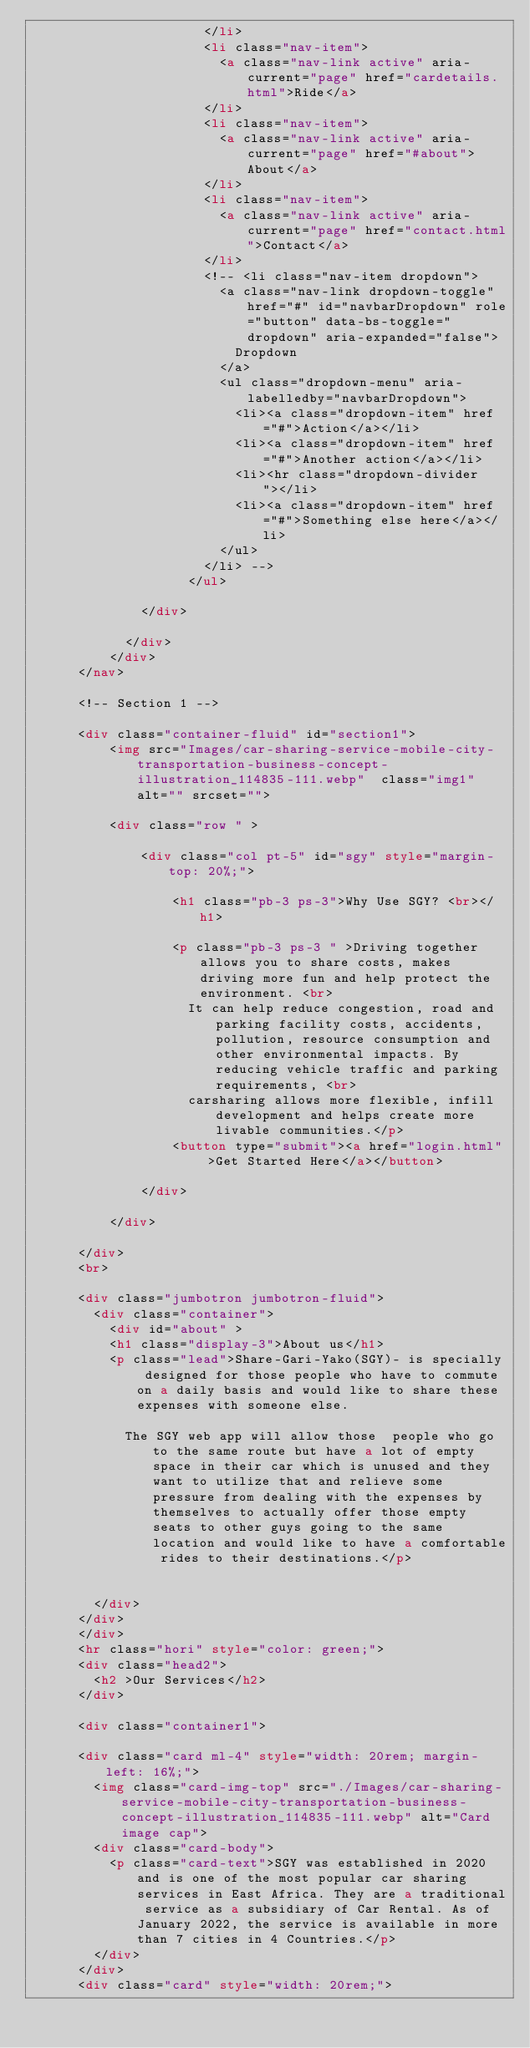Convert code to text. <code><loc_0><loc_0><loc_500><loc_500><_HTML_>                      </li>
                      <li class="nav-item">
                        <a class="nav-link active" aria-current="page" href="cardetails.html">Ride</a>
                      </li>
                      <li class="nav-item">
                        <a class="nav-link active" aria-current="page" href="#about">About</a>
                      </li>
                      <li class="nav-item">
                        <a class="nav-link active" aria-current="page" href="contact.html">Contact</a>
                      </li>
                      <!-- <li class="nav-item dropdown">
                        <a class="nav-link dropdown-toggle" href="#" id="navbarDropdown" role="button" data-bs-toggle="dropdown" aria-expanded="false">
                          Dropdown
                        </a>
                        <ul class="dropdown-menu" aria-labelledby="navbarDropdown">
                          <li><a class="dropdown-item" href="#">Action</a></li>
                          <li><a class="dropdown-item" href="#">Another action</a></li>
                          <li><hr class="dropdown-divider"></li>
                          <li><a class="dropdown-item" href="#">Something else here</a></li>
                        </ul>
                      </li> -->
                    </ul>
  
              </div>
      
            </div>
          </div>
      </nav>
  
      <!-- Section 1 -->
  
      <div class="container-fluid" id="section1">
          <img src="Images/car-sharing-service-mobile-city-transportation-business-concept-illustration_114835-111.webp"  class="img1"  alt="" srcset="">
  
          <div class="row " >
  
              <div class="col pt-5" id="sgy" style="margin-top: 20%;">
  
                  <h1 class="pb-3 ps-3">Why Use SGY? <br></h1>

                  <p class="pb-3 ps-3 " >Driving together allows you to share costs, makes driving more fun and help protect the environment. <br>
                    It can help reduce congestion, road and parking facility costs, accidents, pollution, resource consumption and other environmental impacts. By reducing vehicle traffic and parking requirements, <br> 
                    carsharing allows more flexible, infill development and helps create more livable communities.</p>
                  <button type="submit"><a href="login.html" >Get Started Here</a></button>
  
              </div>

          </div>
  
      </div>
      <br>

      <div class="jumbotron jumbotron-fluid">
        <div class="container">
          <div id="about" >
          <h1 class="display-3">About us</h1>
          <p class="lead">Share-Gari-Yako(SGY)- is specially designed for those people who have to commute on a daily basis and would like to share these expenses with someone else.  

            The SGY web app will allow those  people who go to the same route but have a lot of empty space in their car which is unused and they want to utilize that and relieve some pressure from dealing with the expenses by themselves to actually offer those empty seats to other guys going to the same location and would like to have a comfortable rides to their destinations.</p>
          
         
        </div>
      </div>
      </div>
      <hr class="hori" style="color: green;">
      <div class="head2">
        <h2 >Our Services</h2>
      </div>
      
      <div class="container1">
      
      <div class="card ml-4" style="width: 20rem; margin-left: 16%;">
        <img class="card-img-top" src="./Images/car-sharing-service-mobile-city-transportation-business-concept-illustration_114835-111.webp" alt="Card image cap">
        <div class="card-body">
          <p class="card-text">SGY was established in 2020 and is one of the most popular car sharing services in East Africa. They are a traditional service as a subsidiary of Car Rental. As of January 2022, the service is available in more than 7 cities in 4 Countries.</p>
        </div>
      </div>
      <div class="card" style="width: 20rem;"></code> 